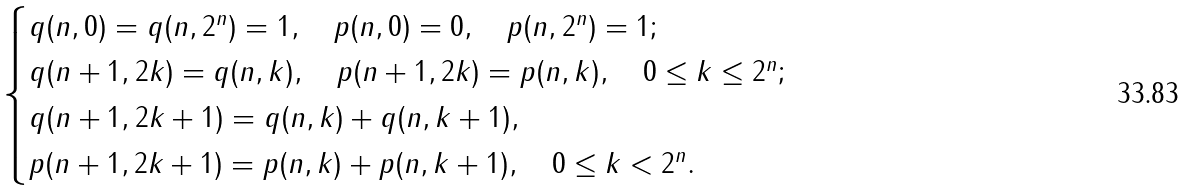Convert formula to latex. <formula><loc_0><loc_0><loc_500><loc_500>\begin{cases} q ( n , 0 ) = q ( n , 2 ^ { n } ) = 1 , \quad p ( n , 0 ) = 0 , \quad p ( n , 2 ^ { n } ) = 1 ; \\ q ( n + 1 , 2 k ) = q ( n , k ) , \quad p ( n + 1 , 2 k ) = p ( n , k ) , \quad 0 \leq k \leq 2 ^ { n } ; \\ q ( n + 1 , 2 k + 1 ) = q ( n , k ) + q ( n , k + 1 ) , \\ p ( n + 1 , 2 k + 1 ) = p ( n , k ) + p ( n , k + 1 ) , \quad 0 \leq k < 2 ^ { n } . \end{cases}</formula> 